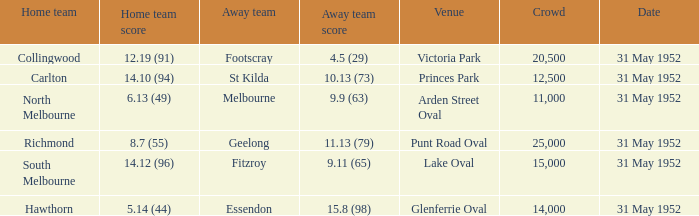Who was the visiting team at the match at victoria park? Footscray. Could you help me parse every detail presented in this table? {'header': ['Home team', 'Home team score', 'Away team', 'Away team score', 'Venue', 'Crowd', 'Date'], 'rows': [['Collingwood', '12.19 (91)', 'Footscray', '4.5 (29)', 'Victoria Park', '20,500', '31 May 1952'], ['Carlton', '14.10 (94)', 'St Kilda', '10.13 (73)', 'Princes Park', '12,500', '31 May 1952'], ['North Melbourne', '6.13 (49)', 'Melbourne', '9.9 (63)', 'Arden Street Oval', '11,000', '31 May 1952'], ['Richmond', '8.7 (55)', 'Geelong', '11.13 (79)', 'Punt Road Oval', '25,000', '31 May 1952'], ['South Melbourne', '14.12 (96)', 'Fitzroy', '9.11 (65)', 'Lake Oval', '15,000', '31 May 1952'], ['Hawthorn', '5.14 (44)', 'Essendon', '15.8 (98)', 'Glenferrie Oval', '14,000', '31 May 1952']]} 